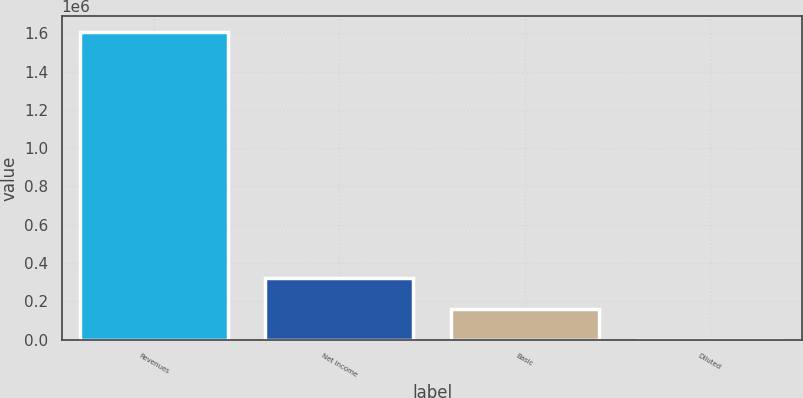<chart> <loc_0><loc_0><loc_500><loc_500><bar_chart><fcel>Revenues<fcel>Net income<fcel>Basic<fcel>Diluted<nl><fcel>1.6086e+06<fcel>321721<fcel>160861<fcel>1.17<nl></chart> 